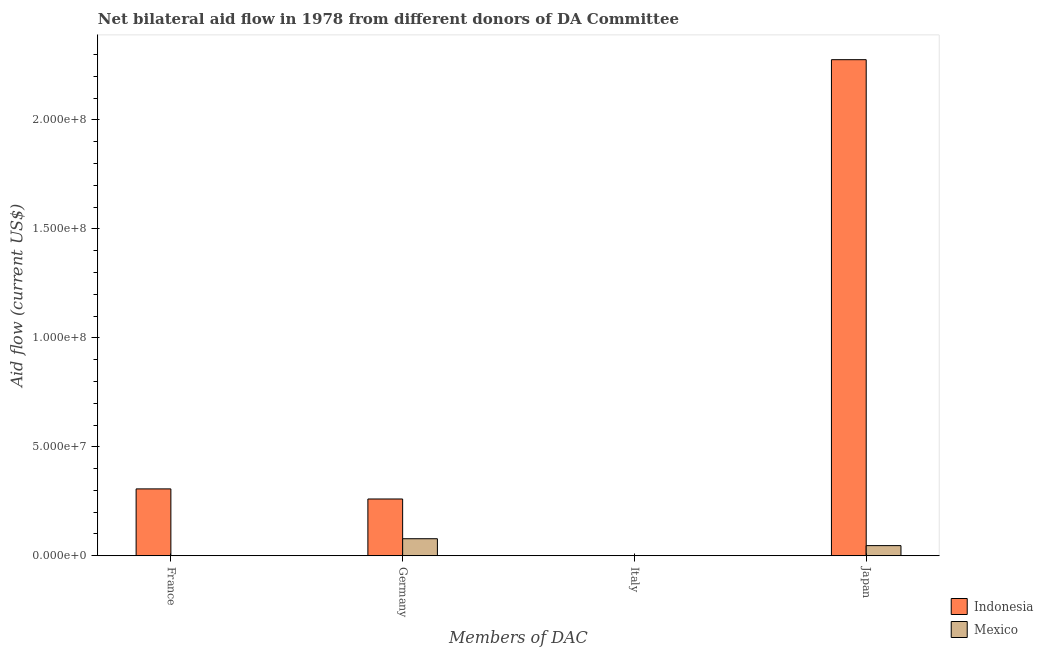How many different coloured bars are there?
Offer a terse response. 2. How many bars are there on the 2nd tick from the left?
Provide a succinct answer. 2. What is the amount of aid given by france in Mexico?
Provide a succinct answer. 0. Across all countries, what is the maximum amount of aid given by japan?
Your answer should be very brief. 2.28e+08. Across all countries, what is the minimum amount of aid given by france?
Offer a very short reply. 0. In which country was the amount of aid given by germany maximum?
Your answer should be very brief. Indonesia. What is the total amount of aid given by germany in the graph?
Offer a terse response. 3.39e+07. What is the difference between the amount of aid given by germany in Indonesia and that in Mexico?
Keep it short and to the point. 1.82e+07. What is the difference between the amount of aid given by japan in Mexico and the amount of aid given by germany in Indonesia?
Provide a short and direct response. -2.14e+07. What is the average amount of aid given by germany per country?
Offer a terse response. 1.69e+07. What is the difference between the amount of aid given by germany and amount of aid given by japan in Mexico?
Keep it short and to the point. 3.16e+06. In how many countries, is the amount of aid given by japan greater than 100000000 US$?
Your answer should be compact. 1. What is the ratio of the amount of aid given by japan in Indonesia to that in Mexico?
Your response must be concise. 48.73. Is the amount of aid given by germany in Mexico less than that in Indonesia?
Give a very brief answer. Yes. Is the difference between the amount of aid given by germany in Mexico and Indonesia greater than the difference between the amount of aid given by japan in Mexico and Indonesia?
Offer a terse response. Yes. What is the difference between the highest and the second highest amount of aid given by japan?
Your answer should be very brief. 2.23e+08. What is the difference between the highest and the lowest amount of aid given by france?
Make the answer very short. 3.07e+07. In how many countries, is the amount of aid given by france greater than the average amount of aid given by france taken over all countries?
Provide a succinct answer. 1. Is it the case that in every country, the sum of the amount of aid given by germany and amount of aid given by japan is greater than the sum of amount of aid given by italy and amount of aid given by france?
Keep it short and to the point. No. What is the difference between two consecutive major ticks on the Y-axis?
Offer a very short reply. 5.00e+07. Does the graph contain grids?
Provide a succinct answer. No. How are the legend labels stacked?
Ensure brevity in your answer.  Vertical. What is the title of the graph?
Keep it short and to the point. Net bilateral aid flow in 1978 from different donors of DA Committee. What is the label or title of the X-axis?
Ensure brevity in your answer.  Members of DAC. What is the Aid flow (current US$) in Indonesia in France?
Provide a short and direct response. 3.07e+07. What is the Aid flow (current US$) of Mexico in France?
Make the answer very short. 0. What is the Aid flow (current US$) of Indonesia in Germany?
Make the answer very short. 2.61e+07. What is the Aid flow (current US$) of Mexico in Germany?
Make the answer very short. 7.83e+06. What is the Aid flow (current US$) in Indonesia in Italy?
Your answer should be very brief. 0. What is the Aid flow (current US$) in Indonesia in Japan?
Offer a very short reply. 2.28e+08. What is the Aid flow (current US$) in Mexico in Japan?
Give a very brief answer. 4.67e+06. Across all Members of DAC, what is the maximum Aid flow (current US$) of Indonesia?
Provide a short and direct response. 2.28e+08. Across all Members of DAC, what is the maximum Aid flow (current US$) of Mexico?
Provide a succinct answer. 7.83e+06. Across all Members of DAC, what is the minimum Aid flow (current US$) of Indonesia?
Your answer should be compact. 0. Across all Members of DAC, what is the minimum Aid flow (current US$) of Mexico?
Give a very brief answer. 0. What is the total Aid flow (current US$) of Indonesia in the graph?
Your response must be concise. 2.84e+08. What is the total Aid flow (current US$) in Mexico in the graph?
Offer a terse response. 1.25e+07. What is the difference between the Aid flow (current US$) in Indonesia in France and that in Germany?
Give a very brief answer. 4.63e+06. What is the difference between the Aid flow (current US$) of Indonesia in France and that in Japan?
Your answer should be very brief. -1.97e+08. What is the difference between the Aid flow (current US$) of Indonesia in Germany and that in Japan?
Offer a very short reply. -2.02e+08. What is the difference between the Aid flow (current US$) in Mexico in Germany and that in Japan?
Provide a succinct answer. 3.16e+06. What is the difference between the Aid flow (current US$) in Indonesia in France and the Aid flow (current US$) in Mexico in Germany?
Your response must be concise. 2.29e+07. What is the difference between the Aid flow (current US$) in Indonesia in France and the Aid flow (current US$) in Mexico in Japan?
Make the answer very short. 2.60e+07. What is the difference between the Aid flow (current US$) of Indonesia in Germany and the Aid flow (current US$) of Mexico in Japan?
Your answer should be very brief. 2.14e+07. What is the average Aid flow (current US$) in Indonesia per Members of DAC?
Your response must be concise. 7.11e+07. What is the average Aid flow (current US$) in Mexico per Members of DAC?
Give a very brief answer. 3.12e+06. What is the difference between the Aid flow (current US$) of Indonesia and Aid flow (current US$) of Mexico in Germany?
Your response must be concise. 1.82e+07. What is the difference between the Aid flow (current US$) of Indonesia and Aid flow (current US$) of Mexico in Japan?
Ensure brevity in your answer.  2.23e+08. What is the ratio of the Aid flow (current US$) in Indonesia in France to that in Germany?
Ensure brevity in your answer.  1.18. What is the ratio of the Aid flow (current US$) of Indonesia in France to that in Japan?
Make the answer very short. 0.13. What is the ratio of the Aid flow (current US$) of Indonesia in Germany to that in Japan?
Give a very brief answer. 0.11. What is the ratio of the Aid flow (current US$) in Mexico in Germany to that in Japan?
Offer a very short reply. 1.68. What is the difference between the highest and the second highest Aid flow (current US$) of Indonesia?
Ensure brevity in your answer.  1.97e+08. What is the difference between the highest and the lowest Aid flow (current US$) of Indonesia?
Your answer should be compact. 2.28e+08. What is the difference between the highest and the lowest Aid flow (current US$) of Mexico?
Your response must be concise. 7.83e+06. 